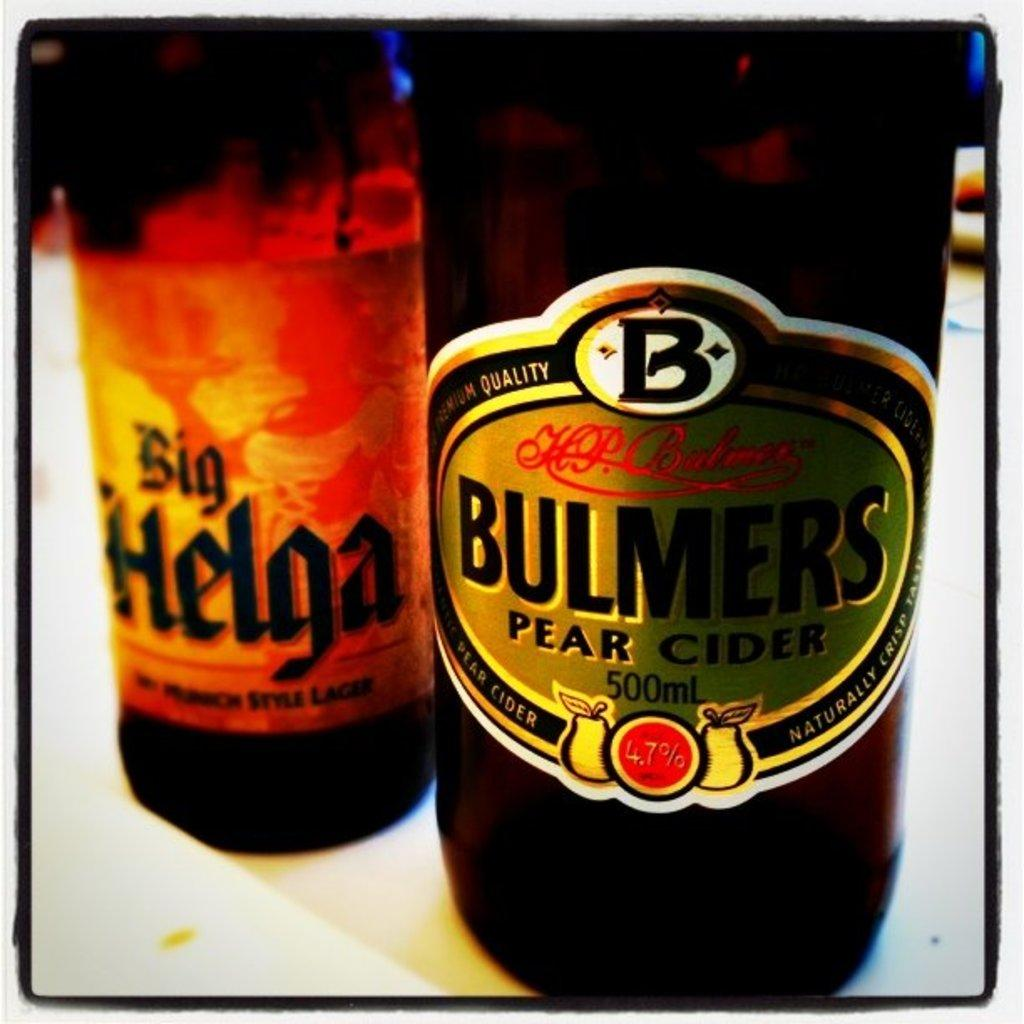<image>
Render a clear and concise summary of the photo. a bottle that is labeled and says 'bulmers pear cider' on it 